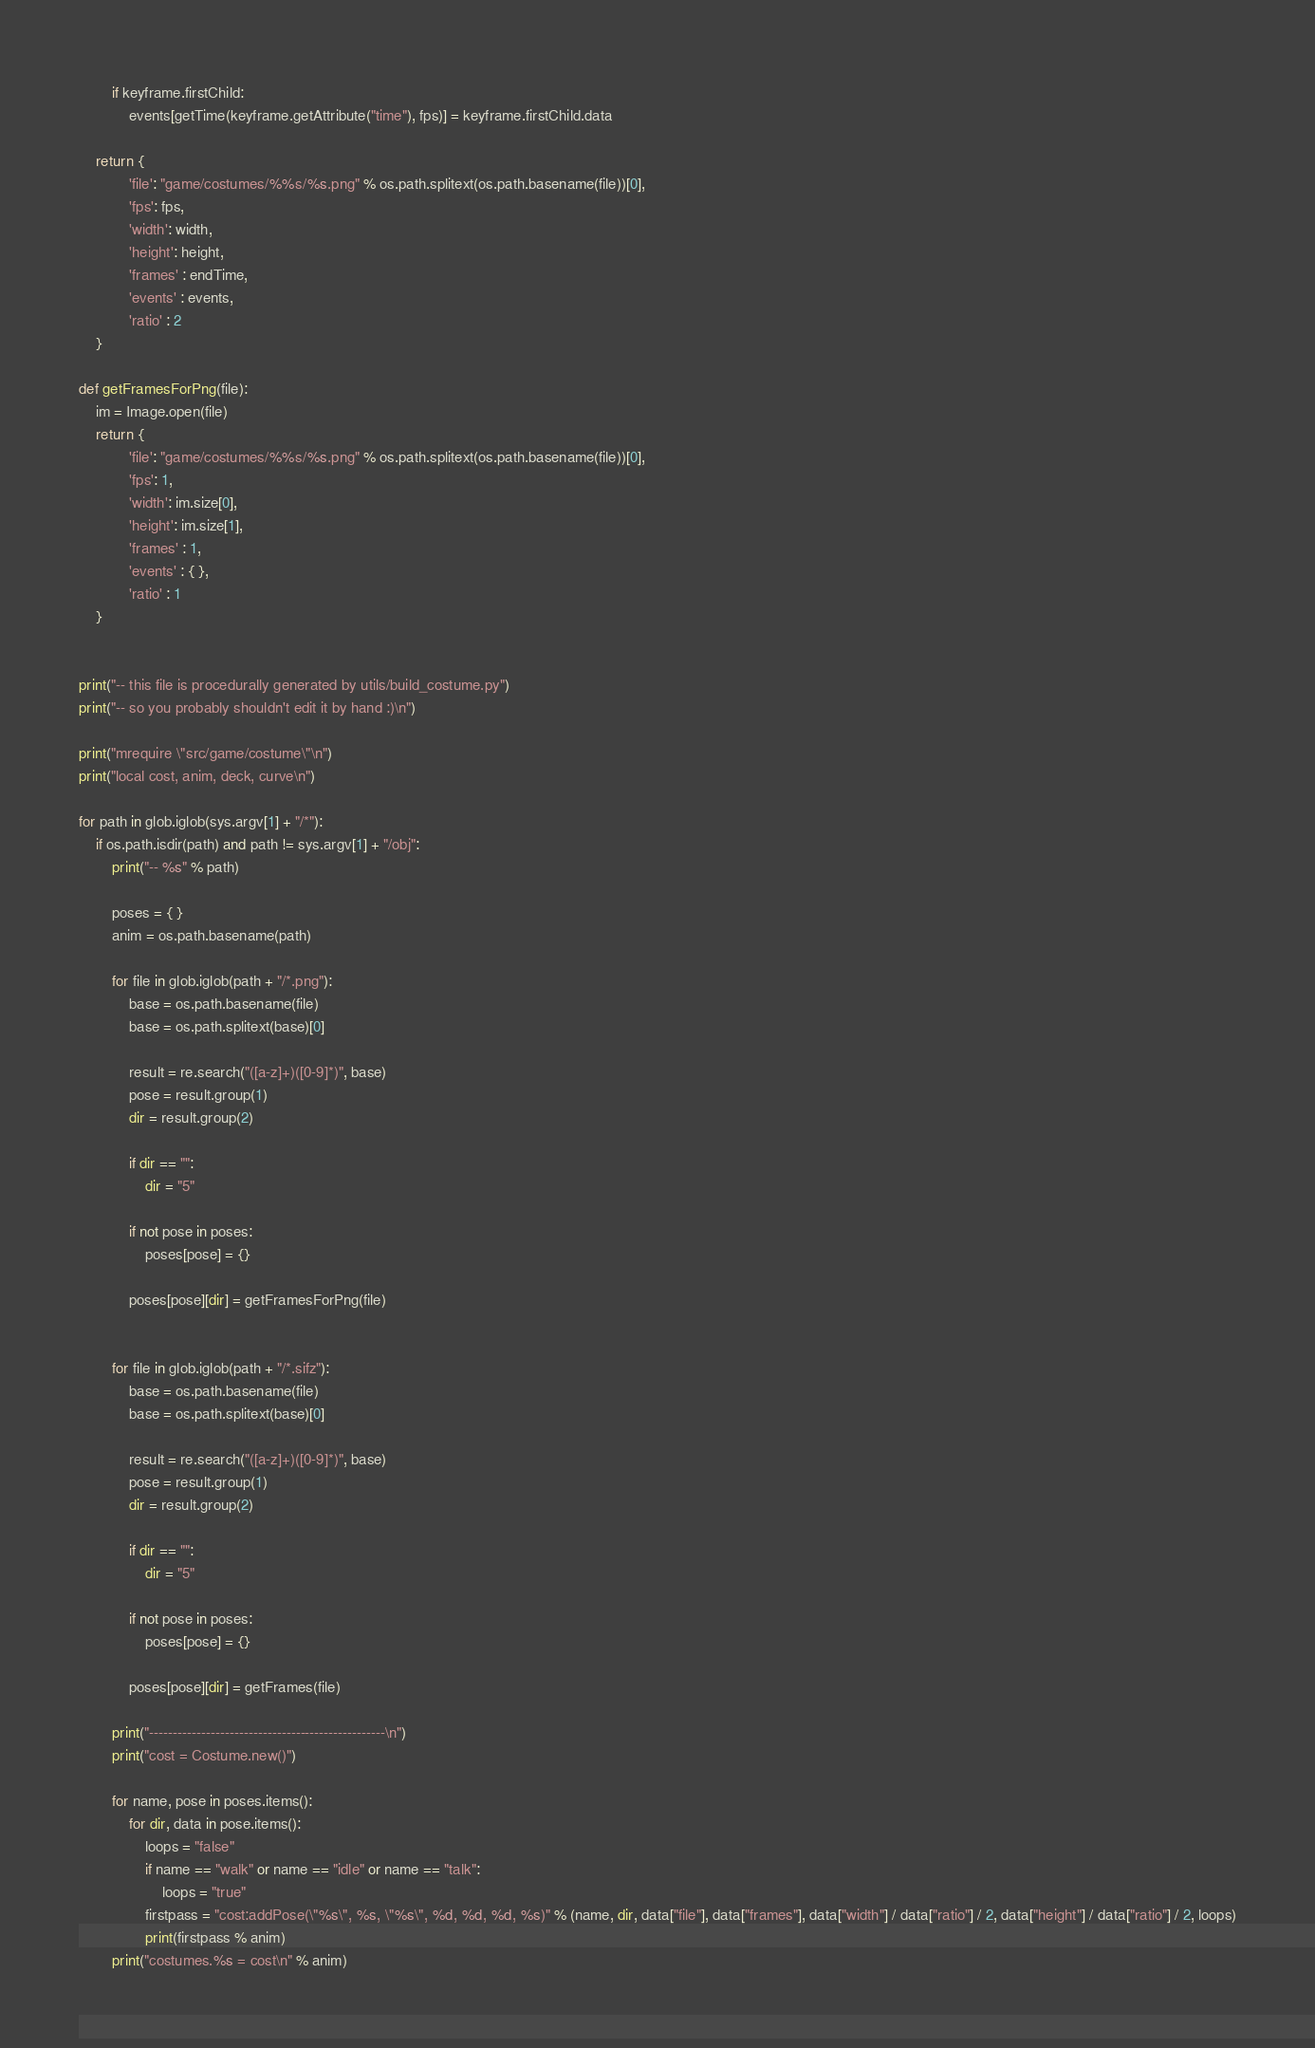Convert code to text. <code><loc_0><loc_0><loc_500><loc_500><_Python_>        if keyframe.firstChild:
            events[getTime(keyframe.getAttribute("time"), fps)] = keyframe.firstChild.data
    
    return { 
            'file': "game/costumes/%%s/%s.png" % os.path.splitext(os.path.basename(file))[0],
            'fps': fps,
            'width': width,
            'height': height,
            'frames' : endTime,
            'events' : events,
            'ratio' : 2
    }

def getFramesForPng(file):
    im = Image.open(file)
    return { 
            'file': "game/costumes/%%s/%s.png" % os.path.splitext(os.path.basename(file))[0],
            'fps': 1,
            'width': im.size[0],
            'height': im.size[1],
            'frames' : 1,
            'events' : { },
            'ratio' : 1
    }


print("-- this file is procedurally generated by utils/build_costume.py")
print("-- so you probably shouldn't edit it by hand :)\n")

print("mrequire \"src/game/costume\"\n")
print("local cost, anim, deck, curve\n")

for path in glob.iglob(sys.argv[1] + "/*"):
    if os.path.isdir(path) and path != sys.argv[1] + "/obj":
        print("-- %s" % path)
        
        poses = { }
        anim = os.path.basename(path)
        
        for file in glob.iglob(path + "/*.png"):
            base = os.path.basename(file)
            base = os.path.splitext(base)[0]
            
            result = re.search("([a-z]+)([0-9]*)", base)
            pose = result.group(1)
            dir = result.group(2)
            
            if dir == "":
                dir = "5"
            
            if not pose in poses:
                poses[pose] = {}
                
            poses[pose][dir] = getFramesForPng(file)


        for file in glob.iglob(path + "/*.sifz"):
            base = os.path.basename(file)
            base = os.path.splitext(base)[0]
            
            result = re.search("([a-z]+)([0-9]*)", base)
            pose = result.group(1)
            dir = result.group(2)
            
            if dir == "":
                dir = "5"
            
            if not pose in poses:
                poses[pose] = {}
                
            poses[pose][dir] = getFrames(file)
            
        print("--------------------------------------------------\n")
        print("cost = Costume.new()")

        for name, pose in poses.items():
            for dir, data in pose.items():
                loops = "false"
                if name == "walk" or name == "idle" or name == "talk":
                    loops = "true"
                firstpass = "cost:addPose(\"%s\", %s, \"%s\", %d, %d, %d, %s)" % (name, dir, data["file"], data["frames"], data["width"] / data["ratio"] / 2, data["height"] / data["ratio"] / 2, loops)
                print(firstpass % anim)
        print("costumes.%s = cost\n" % anim)
</code> 